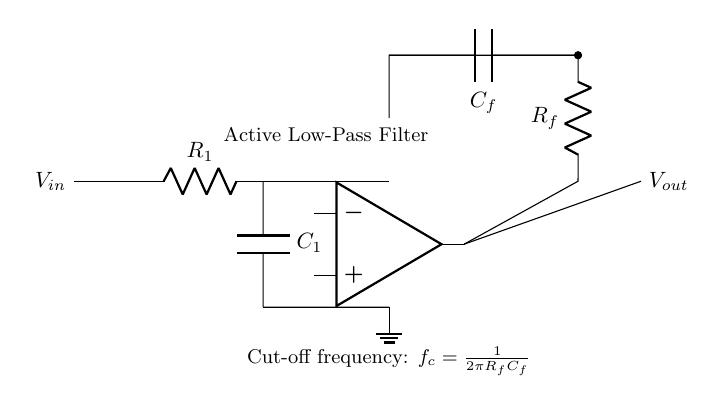What type of filter is implemented in this circuit? The circuit diagram is labeled as an "Active Low-Pass Filter," indicating that it allows low-frequency signals to pass while attenuating higher frequencies.
Answer: Active Low-Pass Filter What components are used in the feedback network? The feedback network includes a resistor labeled as R_f and a capacitor labeled as C_f, connecting the output of the operational amplifier back to its inverting input.
Answer: R_f and C_f What is the expression for cut-off frequency in this circuit? The circuit specifies the formula for the cut-off frequency as f_c = 1/(2πR_fC_f), which indicates how the cut-off frequency is determined by the resistor and capacitor values in the feedback network.
Answer: 1/(2πR_fC_f) How many resistors are present in the circuit? The circuit includes two resistors: one labeled R_1 in the input section and the other labeled R_f in the feedback network.
Answer: Two What is the role of the operational amplifier in this circuit? The operational amplifier amplifies the input signal and processes it according to the configuration of the resistors and capacitors, effectively determining the filter characteristics.
Answer: Amplification What is the significance of the ground connection? The ground connection serves as a reference point for the circuit, ensuring that all voltage measurements are made relative to this common potential, important for proper circuit operation.
Answer: Reference point What is the effect of increasing C_f on the cut-off frequency? Increasing the capacitance C_f in the formula for cut-off frequency, f_c = 1/(2πR_fC_f), would decrease the cut-off frequency, allowing lower frequencies to be passed through.
Answer: Decrease the cut-off frequency 